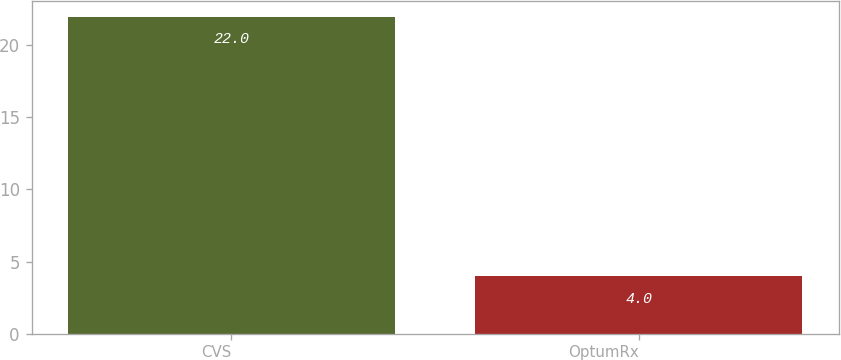<chart> <loc_0><loc_0><loc_500><loc_500><bar_chart><fcel>CVS<fcel>OptumRx<nl><fcel>22<fcel>4<nl></chart> 